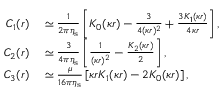<formula> <loc_0><loc_0><loc_500><loc_500>\begin{array} { r l } { C _ { 1 } ( r ) } & \simeq \frac { 1 } { 2 \pi \eta _ { s } } \left [ K _ { 0 } ( \kappa r ) - \frac { 3 } { 4 ( \kappa r ) ^ { 2 } } + \frac { 3 K _ { 1 } ( \kappa r ) } { 4 \kappa r } \right ] , } \\ { C _ { 2 } ( r ) } & \simeq \frac { 3 } { 4 \pi \eta _ { s } } \left [ \frac { 1 } { ( \kappa r ) ^ { 2 } } - \frac { K _ { 2 } ( \kappa r ) } { 2 } \right ] , } \\ { C _ { 3 } ( r ) } & \simeq \frac { \mu } { 1 6 \pi \eta _ { s } } \left [ \kappa r K _ { 1 } ( \kappa r ) - 2 K _ { 0 } ( \kappa r ) \right ] , } \end{array}</formula> 